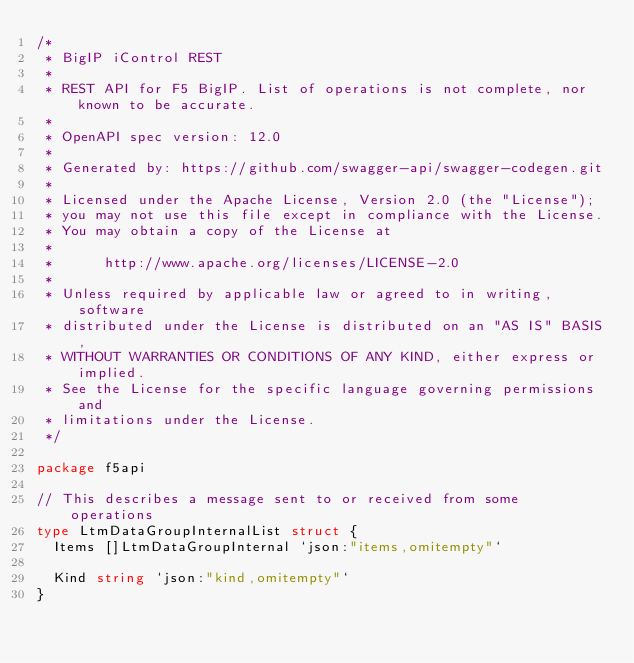Convert code to text. <code><loc_0><loc_0><loc_500><loc_500><_Go_>/*
 * BigIP iControl REST
 *
 * REST API for F5 BigIP. List of operations is not complete, nor known to be accurate.
 *
 * OpenAPI spec version: 12.0
 *
 * Generated by: https://github.com/swagger-api/swagger-codegen.git
 *
 * Licensed under the Apache License, Version 2.0 (the "License");
 * you may not use this file except in compliance with the License.
 * You may obtain a copy of the License at
 *
 *      http://www.apache.org/licenses/LICENSE-2.0
 *
 * Unless required by applicable law or agreed to in writing, software
 * distributed under the License is distributed on an "AS IS" BASIS,
 * WITHOUT WARRANTIES OR CONDITIONS OF ANY KIND, either express or implied.
 * See the License for the specific language governing permissions and
 * limitations under the License.
 */

package f5api

// This describes a message sent to or received from some operations
type LtmDataGroupInternalList struct {
	Items []LtmDataGroupInternal `json:"items,omitempty"`

	Kind string `json:"kind,omitempty"`
}
</code> 